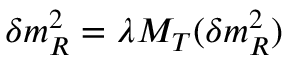<formula> <loc_0><loc_0><loc_500><loc_500>\delta m _ { R } ^ { 2 } = \lambda M _ { T } ( \delta m _ { R } ^ { 2 } )</formula> 